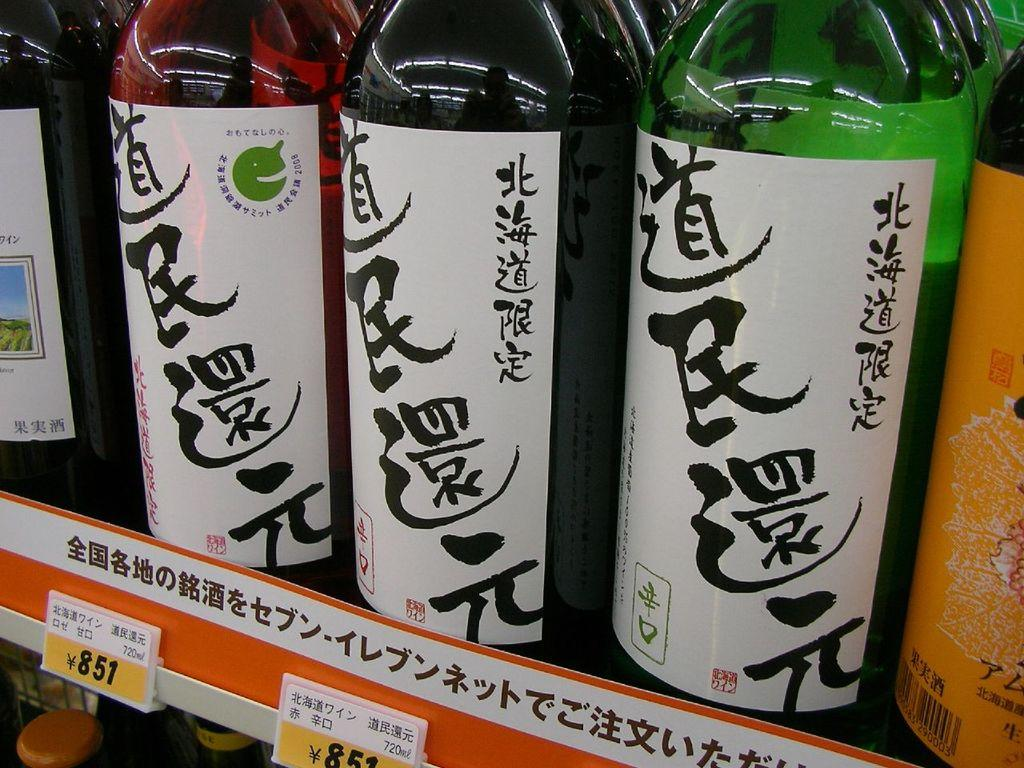<image>
Offer a succinct explanation of the picture presented. Three bottles with Chinese writing on it with a label underneath saying 851 